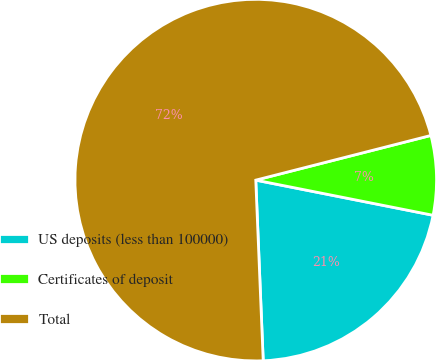<chart> <loc_0><loc_0><loc_500><loc_500><pie_chart><fcel>US deposits (less than 100000)<fcel>Certificates of deposit<fcel>Total<nl><fcel>21.23%<fcel>7.09%<fcel>71.68%<nl></chart> 